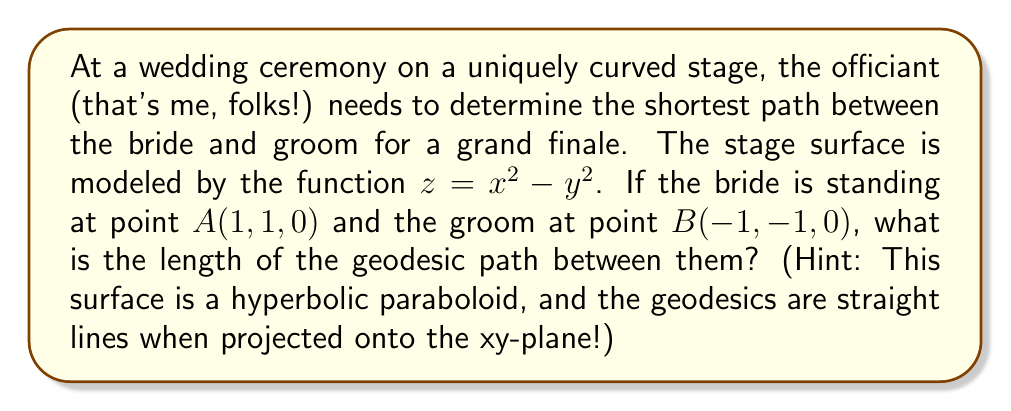Help me with this question. Let's approach this step-by-step:

1) First, we need to understand that on a hyperbolic paraboloid, the geodesics (shortest paths) are straight lines when projected onto the xy-plane. This is a unique property of this surface.

2) Given that the bride is at $A(1, 1, 0)$ and the groom at $B(-1, -1, 0)$, we can see that the straight line connecting these points in the xy-plane is the diagonal of a square.

3) To find the length of this path, we need to calculate the distance between these points in 3D space. We can use the 3D distance formula:

   $$d = \sqrt{(x_2-x_1)^2 + (y_2-y_1)^2 + (z_2-z_1)^2}$$

4) We know $x_1 = 1$, $y_1 = 1$, $x_2 = -1$, $y_2 = -1$. We need to find $z_1$ and $z_2$.

5) Using the surface equation $z = x^2 - y^2$:
   For $A$: $z_1 = 1^2 - 1^2 = 0$
   For $B$: $z_2 = (-1)^2 - (-1)^2 = 0$

6) Now we can plug these into our distance formula:

   $$d = \sqrt{(-1-1)^2 + (-1-1)^2 + (0-0)^2}$$
   $$d = \sqrt{(-2)^2 + (-2)^2 + 0^2}$$
   $$d = \sqrt{4 + 4 + 0}$$
   $$d = \sqrt{8}$$
   $$d = 2\sqrt{2}$$

7) Therefore, the length of the geodesic path is $2\sqrt{2}$ units.
Answer: The length of the geodesic path between the bride and groom is $2\sqrt{2}$ units. 